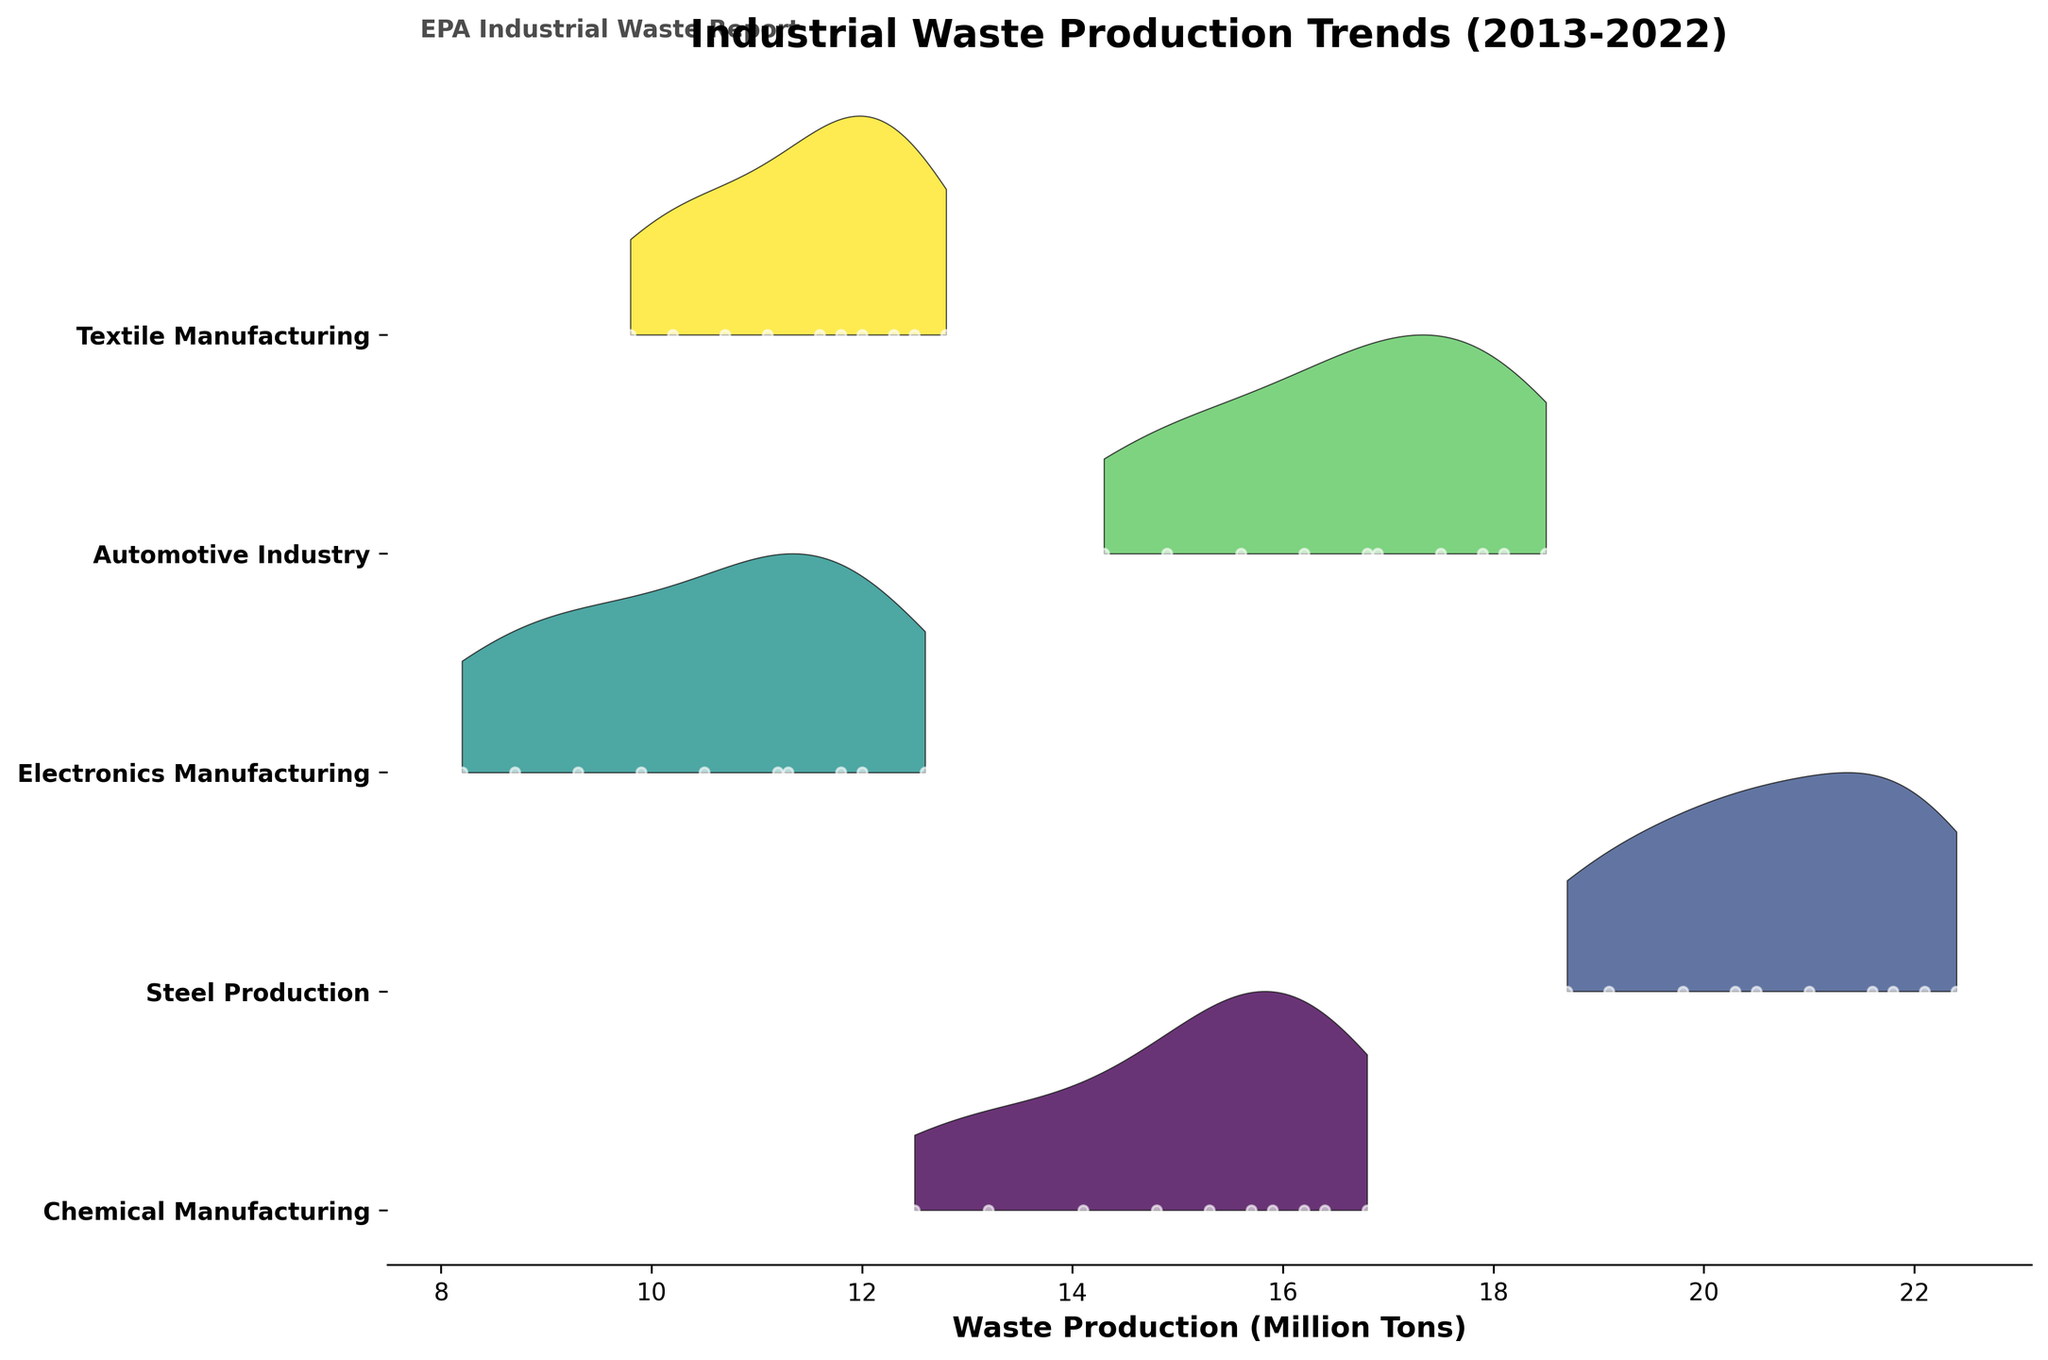What is the title of the figure? The title of the figure is prominently displayed at the top of the plot. It reads 'Industrial Waste Production Trends (2013-2022)'.
Answer: Industrial Waste Production Trends (2013-2022) How many industries are represented in the figure? The figure shows a separate ridge for each industry, marked on the y-axis. Counting these labels gives the number of industries.
Answer: 5 Which industry had the highest waste production in 2022? By looking at the ridgelines for the year 2022, we compare the peaks of each ridge. The Steel Production ridge is the highest.
Answer: Steel Production Which year did the Automotive Industry have its lowest waste production? Observe the Automotive Industry ridge and its plots. The year 2013 has the lowest point.
Answer: 2013 How does the waste production trend of Electronics Manufacturing change over the decade? Look at the Electronics Manufacturing ridge from left (2013) to right (2022). The trend shows an overall increase in waste production, peaking in the later years.
Answer: Increases In which year did the Textile Manufacturing see a decrease in waste production compared to the previous year? Examine the Textile Manufacturing ridge for years where the values decrease from the previous year. The ridge dips in 2020 compared to 2019.
Answer: 2020 Compare the waste production trends of the Chemical Manufacturing and Steel Production industries over the decade. Both ridges should be examined from 2013 to 2022. Chemical Manufacturing shows a consistent increase with a slight dip in 2020, whereas Steel Production also increases steadily with a dip in 2020 and a rise again.
Answer: Similar rising trends, both dip in 2020 Identify the industry with the least variance in waste production over the decade. The ridge with the narrowest spread and least variation between the highest and lowest points represents the industry with the least variance. Electronics Manufacturing has a notable narrow spread.
Answer: Electronics Manufacturing What is the trend in average waste production for all industries combined from 2013 to 2022? Calculate the average waste production for each year by summing the values and dividing by the number of industries, then observe the trend from 2013 to 2022. Overall, the average waste production tends to increase.
Answer: Increasing trend 